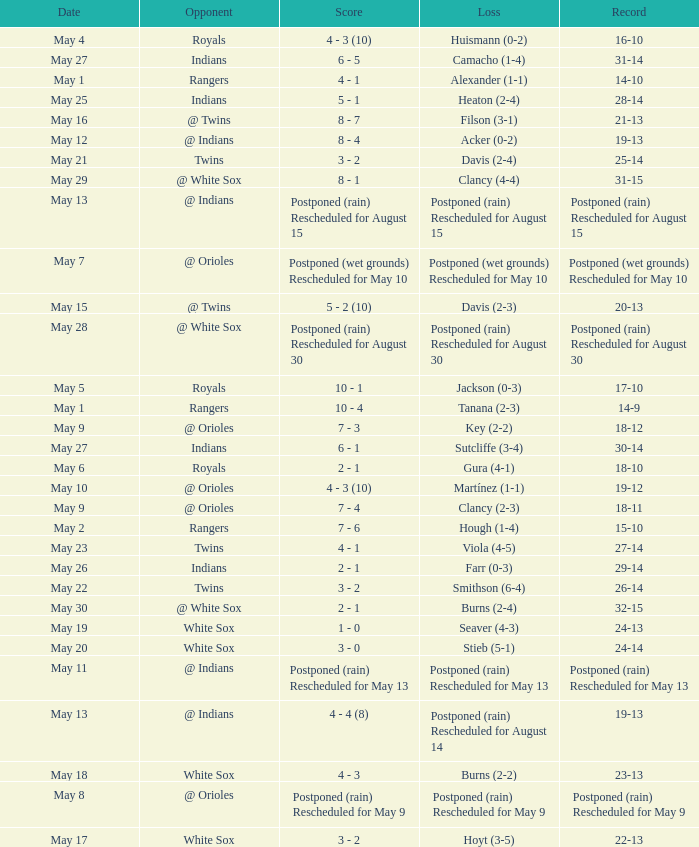What was date of the game when the record was 31-15? May 29. 